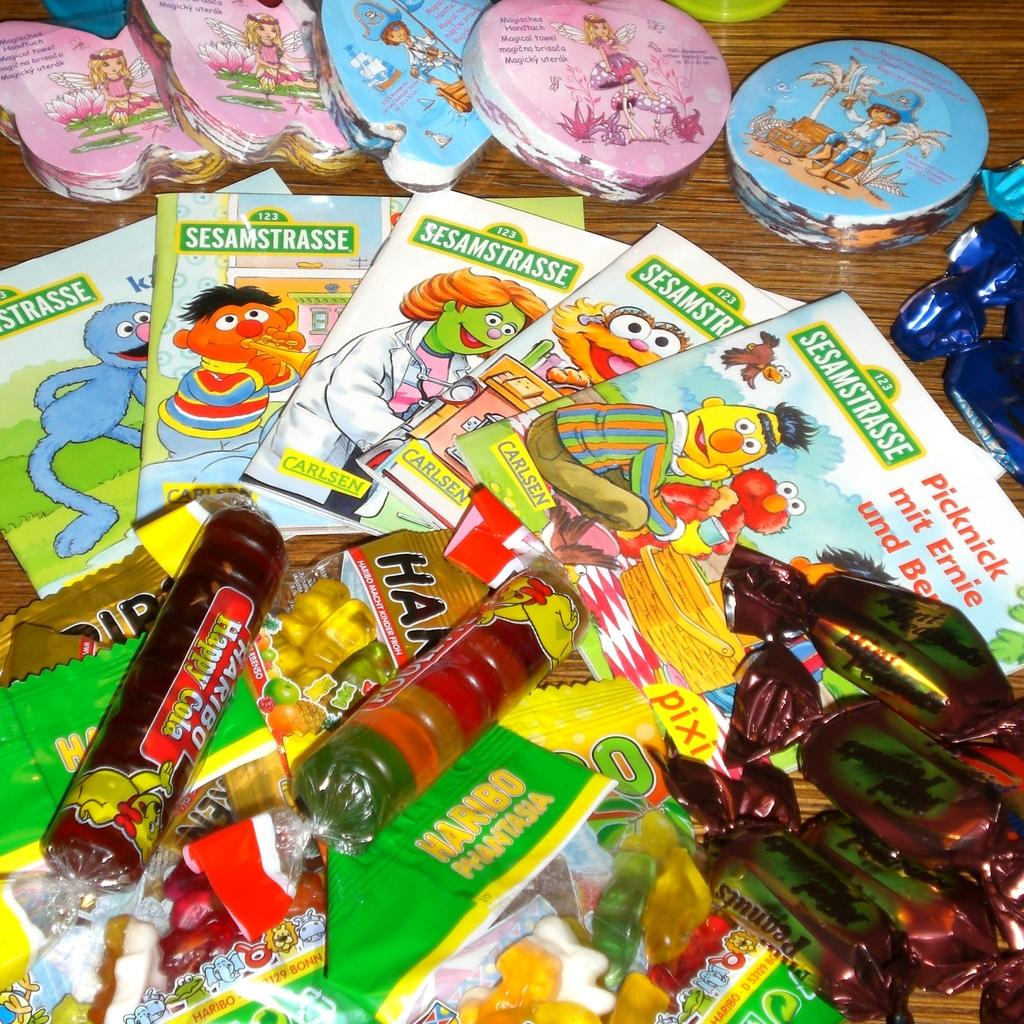What type of food items can be seen on the table in the image? There are chocolates and candies on the table in the image. What else can be found on the table besides food items? There are books and other objects on the table. How many food items are arranged on the table? The chocolates and candies are arranged on the table, along with the books and other objects. What type of soup is being served in the image? There is no soup present in the image; it only shows chocolates, candies, books, and other objects on the table. Is there a bear sitting at the table in the image? There is no bear present in the image; it only shows chocolates, candies, books, and other objects on the table. 